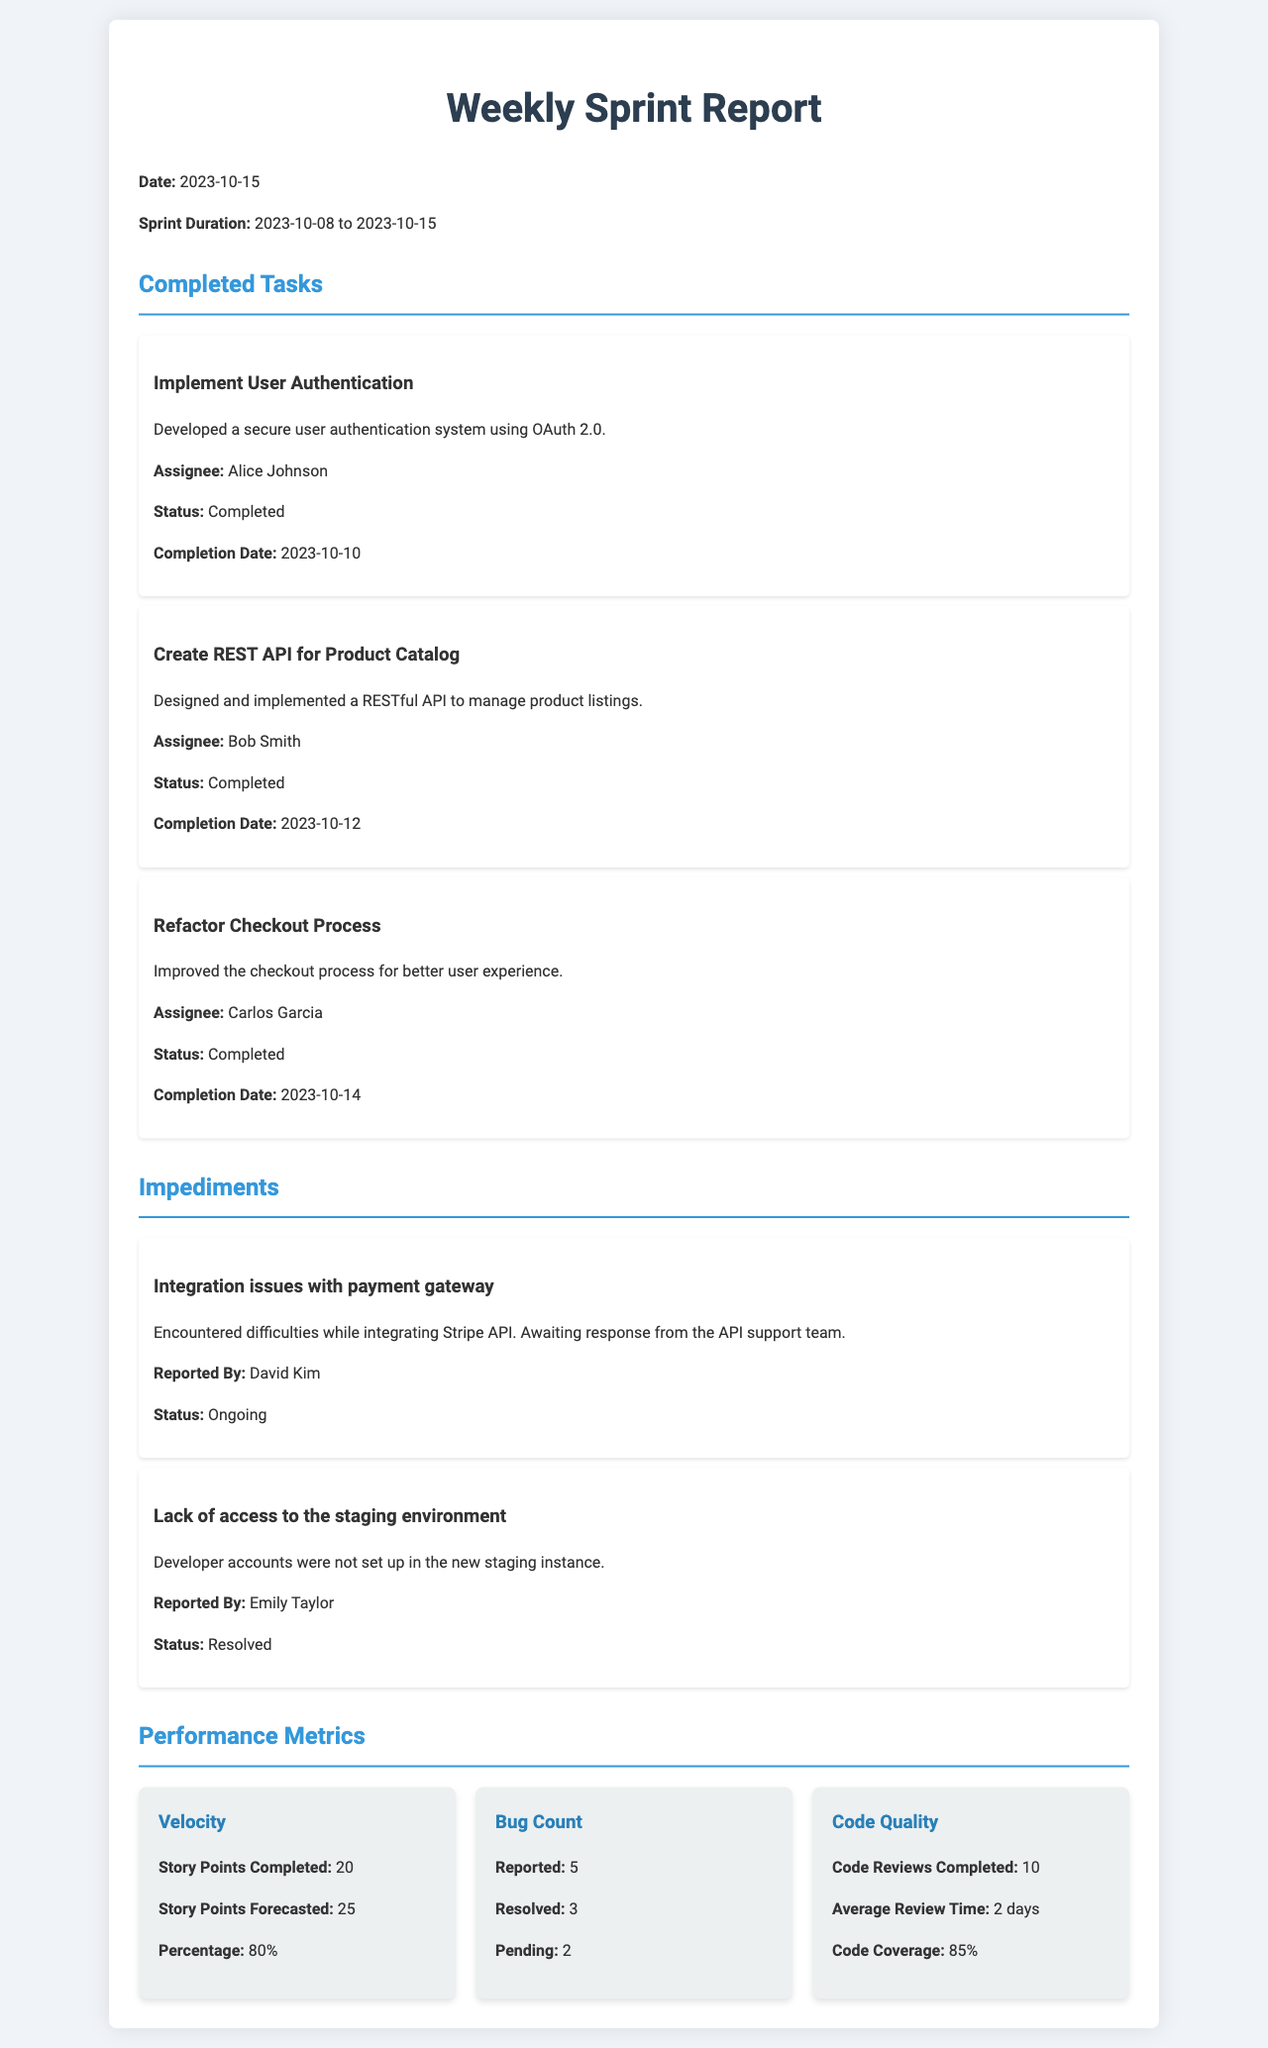what is the date of the sprint report? The date of the sprint report is explicitly stated in the document.
Answer: 2023-10-15 how many story points were completed? The document lists the completed story points under the performance metrics section.
Answer: 20 who was responsible for implementing user authentication? The assignee of the task is identified within the completed tasks section.
Answer: Alice Johnson what is the status of the impediment related to the payment gateway? The document specifies the status of each impediment listed.
Answer: Ongoing how many bugs were reported in total? The total number of reported bugs is shown in the performance metrics section of the report.
Answer: 5 what percentage of story points was completed? The document indicates the percentage of story points completed as part of the performance metrics.
Answer: 80% which task was completed by Bob Smith? The completed tasks section clearly specifies each task along with the assignee's name.
Answer: Create REST API for Product Catalog what was the average review time for code quality? The performance metrics section provides insights into code quality, including review time.
Answer: 2 days how many impediments are listed in total? The document outlines the number of impediments mentioned, helping to assess project challenges.
Answer: 2 